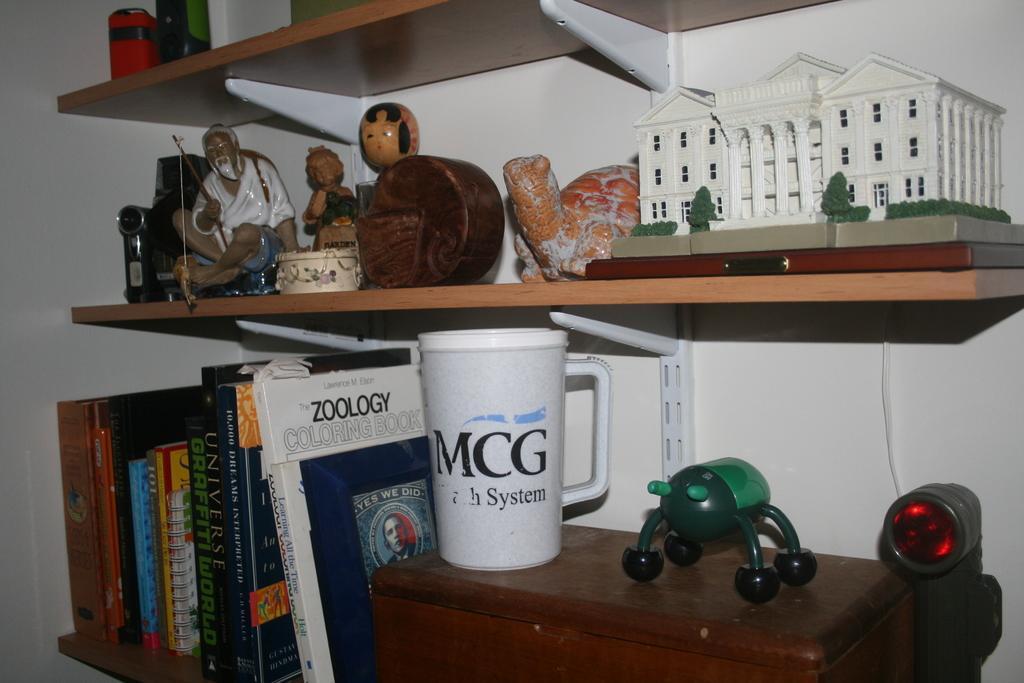In one or two sentences, can you explain what this image depicts? In this image i can see few books, mug, a toy building on a rack at the back ground i can see a wall. 